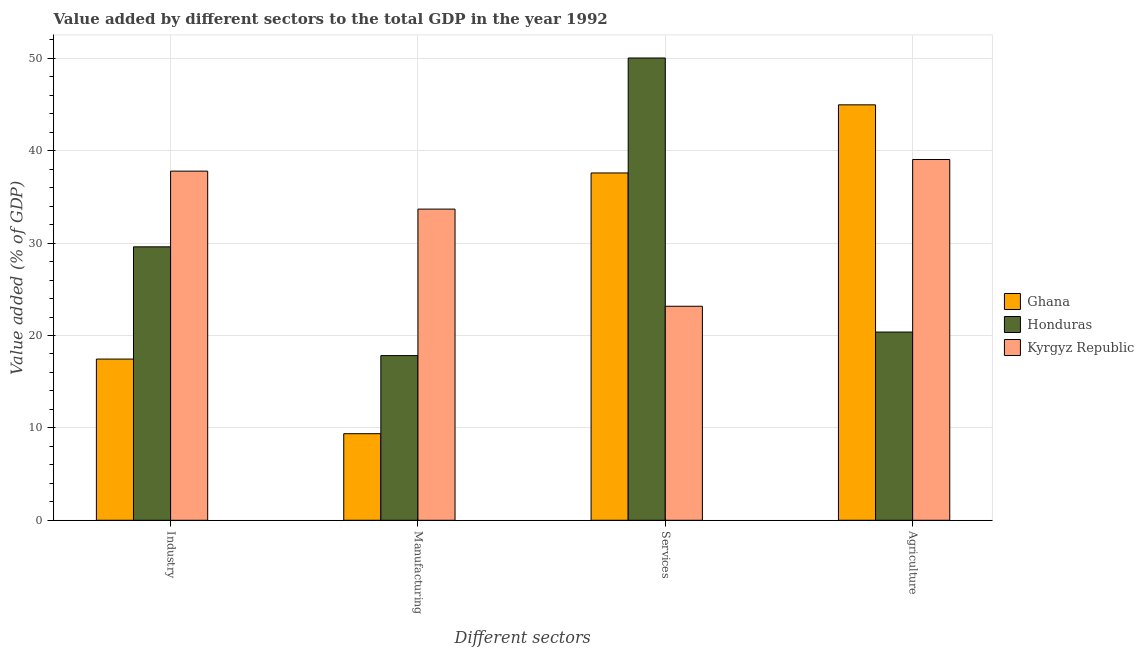Are the number of bars per tick equal to the number of legend labels?
Provide a short and direct response. Yes. Are the number of bars on each tick of the X-axis equal?
Provide a succinct answer. Yes. What is the label of the 1st group of bars from the left?
Make the answer very short. Industry. What is the value added by services sector in Kyrgyz Republic?
Ensure brevity in your answer.  23.16. Across all countries, what is the maximum value added by services sector?
Your response must be concise. 50.03. Across all countries, what is the minimum value added by agricultural sector?
Your answer should be compact. 20.37. In which country was the value added by industrial sector maximum?
Provide a short and direct response. Kyrgyz Republic. In which country was the value added by services sector minimum?
Provide a short and direct response. Kyrgyz Republic. What is the total value added by agricultural sector in the graph?
Provide a short and direct response. 104.38. What is the difference between the value added by agricultural sector in Kyrgyz Republic and that in Honduras?
Offer a very short reply. 18.68. What is the difference between the value added by agricultural sector in Honduras and the value added by industrial sector in Ghana?
Give a very brief answer. 2.92. What is the average value added by manufacturing sector per country?
Your answer should be very brief. 20.29. What is the difference between the value added by agricultural sector and value added by manufacturing sector in Kyrgyz Republic?
Provide a succinct answer. 5.37. What is the ratio of the value added by services sector in Ghana to that in Kyrgyz Republic?
Offer a terse response. 1.62. Is the value added by industrial sector in Kyrgyz Republic less than that in Honduras?
Keep it short and to the point. No. Is the difference between the value added by services sector in Ghana and Kyrgyz Republic greater than the difference between the value added by agricultural sector in Ghana and Kyrgyz Republic?
Make the answer very short. Yes. What is the difference between the highest and the second highest value added by agricultural sector?
Your answer should be compact. 5.92. What is the difference between the highest and the lowest value added by industrial sector?
Offer a very short reply. 20.34. Is the sum of the value added by manufacturing sector in Honduras and Kyrgyz Republic greater than the maximum value added by agricultural sector across all countries?
Give a very brief answer. Yes. What does the 3rd bar from the left in Services represents?
Provide a short and direct response. Kyrgyz Republic. What does the 1st bar from the right in Industry represents?
Provide a succinct answer. Kyrgyz Republic. How many countries are there in the graph?
Make the answer very short. 3. Does the graph contain grids?
Your response must be concise. Yes. Where does the legend appear in the graph?
Your answer should be compact. Center right. How many legend labels are there?
Your answer should be very brief. 3. What is the title of the graph?
Give a very brief answer. Value added by different sectors to the total GDP in the year 1992. Does "Slovak Republic" appear as one of the legend labels in the graph?
Your answer should be compact. No. What is the label or title of the X-axis?
Keep it short and to the point. Different sectors. What is the label or title of the Y-axis?
Your answer should be compact. Value added (% of GDP). What is the Value added (% of GDP) in Ghana in Industry?
Provide a short and direct response. 17.45. What is the Value added (% of GDP) in Honduras in Industry?
Provide a short and direct response. 29.6. What is the Value added (% of GDP) of Kyrgyz Republic in Industry?
Offer a very short reply. 37.79. What is the Value added (% of GDP) in Ghana in Manufacturing?
Your response must be concise. 9.37. What is the Value added (% of GDP) of Honduras in Manufacturing?
Give a very brief answer. 17.82. What is the Value added (% of GDP) in Kyrgyz Republic in Manufacturing?
Make the answer very short. 33.68. What is the Value added (% of GDP) of Ghana in Services?
Provide a short and direct response. 37.59. What is the Value added (% of GDP) in Honduras in Services?
Your response must be concise. 50.03. What is the Value added (% of GDP) in Kyrgyz Republic in Services?
Your response must be concise. 23.16. What is the Value added (% of GDP) of Ghana in Agriculture?
Your answer should be very brief. 44.96. What is the Value added (% of GDP) of Honduras in Agriculture?
Keep it short and to the point. 20.37. What is the Value added (% of GDP) in Kyrgyz Republic in Agriculture?
Give a very brief answer. 39.05. Across all Different sectors, what is the maximum Value added (% of GDP) in Ghana?
Give a very brief answer. 44.96. Across all Different sectors, what is the maximum Value added (% of GDP) in Honduras?
Offer a terse response. 50.03. Across all Different sectors, what is the maximum Value added (% of GDP) of Kyrgyz Republic?
Ensure brevity in your answer.  39.05. Across all Different sectors, what is the minimum Value added (% of GDP) of Ghana?
Offer a very short reply. 9.37. Across all Different sectors, what is the minimum Value added (% of GDP) of Honduras?
Your response must be concise. 17.82. Across all Different sectors, what is the minimum Value added (% of GDP) of Kyrgyz Republic?
Provide a short and direct response. 23.16. What is the total Value added (% of GDP) of Ghana in the graph?
Your answer should be compact. 109.37. What is the total Value added (% of GDP) of Honduras in the graph?
Provide a short and direct response. 117.82. What is the total Value added (% of GDP) in Kyrgyz Republic in the graph?
Keep it short and to the point. 133.68. What is the difference between the Value added (% of GDP) of Ghana in Industry and that in Manufacturing?
Make the answer very short. 8.08. What is the difference between the Value added (% of GDP) of Honduras in Industry and that in Manufacturing?
Your answer should be compact. 11.77. What is the difference between the Value added (% of GDP) in Kyrgyz Republic in Industry and that in Manufacturing?
Provide a short and direct response. 4.11. What is the difference between the Value added (% of GDP) in Ghana in Industry and that in Services?
Provide a succinct answer. -20.14. What is the difference between the Value added (% of GDP) of Honduras in Industry and that in Services?
Provide a succinct answer. -20.44. What is the difference between the Value added (% of GDP) of Kyrgyz Republic in Industry and that in Services?
Provide a succinct answer. 14.62. What is the difference between the Value added (% of GDP) of Ghana in Industry and that in Agriculture?
Offer a terse response. -27.52. What is the difference between the Value added (% of GDP) in Honduras in Industry and that in Agriculture?
Provide a succinct answer. 9.22. What is the difference between the Value added (% of GDP) in Kyrgyz Republic in Industry and that in Agriculture?
Keep it short and to the point. -1.26. What is the difference between the Value added (% of GDP) in Ghana in Manufacturing and that in Services?
Ensure brevity in your answer.  -28.22. What is the difference between the Value added (% of GDP) of Honduras in Manufacturing and that in Services?
Your answer should be very brief. -32.21. What is the difference between the Value added (% of GDP) of Kyrgyz Republic in Manufacturing and that in Services?
Your answer should be compact. 10.51. What is the difference between the Value added (% of GDP) of Ghana in Manufacturing and that in Agriculture?
Your response must be concise. -35.59. What is the difference between the Value added (% of GDP) in Honduras in Manufacturing and that in Agriculture?
Provide a short and direct response. -2.55. What is the difference between the Value added (% of GDP) in Kyrgyz Republic in Manufacturing and that in Agriculture?
Ensure brevity in your answer.  -5.37. What is the difference between the Value added (% of GDP) in Ghana in Services and that in Agriculture?
Your response must be concise. -7.37. What is the difference between the Value added (% of GDP) of Honduras in Services and that in Agriculture?
Your answer should be very brief. 29.66. What is the difference between the Value added (% of GDP) of Kyrgyz Republic in Services and that in Agriculture?
Offer a terse response. -15.88. What is the difference between the Value added (% of GDP) in Ghana in Industry and the Value added (% of GDP) in Honduras in Manufacturing?
Your answer should be very brief. -0.38. What is the difference between the Value added (% of GDP) in Ghana in Industry and the Value added (% of GDP) in Kyrgyz Republic in Manufacturing?
Keep it short and to the point. -16.23. What is the difference between the Value added (% of GDP) of Honduras in Industry and the Value added (% of GDP) of Kyrgyz Republic in Manufacturing?
Your answer should be very brief. -4.08. What is the difference between the Value added (% of GDP) of Ghana in Industry and the Value added (% of GDP) of Honduras in Services?
Provide a short and direct response. -32.59. What is the difference between the Value added (% of GDP) of Ghana in Industry and the Value added (% of GDP) of Kyrgyz Republic in Services?
Your answer should be very brief. -5.72. What is the difference between the Value added (% of GDP) in Honduras in Industry and the Value added (% of GDP) in Kyrgyz Republic in Services?
Your answer should be very brief. 6.43. What is the difference between the Value added (% of GDP) in Ghana in Industry and the Value added (% of GDP) in Honduras in Agriculture?
Your response must be concise. -2.92. What is the difference between the Value added (% of GDP) in Ghana in Industry and the Value added (% of GDP) in Kyrgyz Republic in Agriculture?
Your answer should be compact. -21.6. What is the difference between the Value added (% of GDP) of Honduras in Industry and the Value added (% of GDP) of Kyrgyz Republic in Agriculture?
Provide a short and direct response. -9.45. What is the difference between the Value added (% of GDP) in Ghana in Manufacturing and the Value added (% of GDP) in Honduras in Services?
Your answer should be compact. -40.66. What is the difference between the Value added (% of GDP) of Ghana in Manufacturing and the Value added (% of GDP) of Kyrgyz Republic in Services?
Give a very brief answer. -13.79. What is the difference between the Value added (% of GDP) in Honduras in Manufacturing and the Value added (% of GDP) in Kyrgyz Republic in Services?
Provide a succinct answer. -5.34. What is the difference between the Value added (% of GDP) in Ghana in Manufacturing and the Value added (% of GDP) in Honduras in Agriculture?
Ensure brevity in your answer.  -11. What is the difference between the Value added (% of GDP) of Ghana in Manufacturing and the Value added (% of GDP) of Kyrgyz Republic in Agriculture?
Provide a succinct answer. -29.68. What is the difference between the Value added (% of GDP) in Honduras in Manufacturing and the Value added (% of GDP) in Kyrgyz Republic in Agriculture?
Your answer should be compact. -21.23. What is the difference between the Value added (% of GDP) in Ghana in Services and the Value added (% of GDP) in Honduras in Agriculture?
Provide a succinct answer. 17.22. What is the difference between the Value added (% of GDP) in Ghana in Services and the Value added (% of GDP) in Kyrgyz Republic in Agriculture?
Provide a succinct answer. -1.46. What is the difference between the Value added (% of GDP) in Honduras in Services and the Value added (% of GDP) in Kyrgyz Republic in Agriculture?
Your answer should be compact. 10.99. What is the average Value added (% of GDP) in Ghana per Different sectors?
Provide a short and direct response. 27.34. What is the average Value added (% of GDP) in Honduras per Different sectors?
Your answer should be compact. 29.46. What is the average Value added (% of GDP) in Kyrgyz Republic per Different sectors?
Your response must be concise. 33.42. What is the difference between the Value added (% of GDP) of Ghana and Value added (% of GDP) of Honduras in Industry?
Your answer should be compact. -12.15. What is the difference between the Value added (% of GDP) in Ghana and Value added (% of GDP) in Kyrgyz Republic in Industry?
Provide a short and direct response. -20.34. What is the difference between the Value added (% of GDP) in Honduras and Value added (% of GDP) in Kyrgyz Republic in Industry?
Provide a short and direct response. -8.19. What is the difference between the Value added (% of GDP) of Ghana and Value added (% of GDP) of Honduras in Manufacturing?
Offer a very short reply. -8.45. What is the difference between the Value added (% of GDP) of Ghana and Value added (% of GDP) of Kyrgyz Republic in Manufacturing?
Give a very brief answer. -24.31. What is the difference between the Value added (% of GDP) of Honduras and Value added (% of GDP) of Kyrgyz Republic in Manufacturing?
Ensure brevity in your answer.  -15.86. What is the difference between the Value added (% of GDP) of Ghana and Value added (% of GDP) of Honduras in Services?
Give a very brief answer. -12.44. What is the difference between the Value added (% of GDP) in Ghana and Value added (% of GDP) in Kyrgyz Republic in Services?
Provide a short and direct response. 14.43. What is the difference between the Value added (% of GDP) in Honduras and Value added (% of GDP) in Kyrgyz Republic in Services?
Offer a terse response. 26.87. What is the difference between the Value added (% of GDP) of Ghana and Value added (% of GDP) of Honduras in Agriculture?
Make the answer very short. 24.59. What is the difference between the Value added (% of GDP) of Ghana and Value added (% of GDP) of Kyrgyz Republic in Agriculture?
Your response must be concise. 5.92. What is the difference between the Value added (% of GDP) in Honduras and Value added (% of GDP) in Kyrgyz Republic in Agriculture?
Make the answer very short. -18.68. What is the ratio of the Value added (% of GDP) in Ghana in Industry to that in Manufacturing?
Make the answer very short. 1.86. What is the ratio of the Value added (% of GDP) in Honduras in Industry to that in Manufacturing?
Provide a succinct answer. 1.66. What is the ratio of the Value added (% of GDP) in Kyrgyz Republic in Industry to that in Manufacturing?
Offer a very short reply. 1.12. What is the ratio of the Value added (% of GDP) of Ghana in Industry to that in Services?
Make the answer very short. 0.46. What is the ratio of the Value added (% of GDP) in Honduras in Industry to that in Services?
Provide a short and direct response. 0.59. What is the ratio of the Value added (% of GDP) of Kyrgyz Republic in Industry to that in Services?
Your response must be concise. 1.63. What is the ratio of the Value added (% of GDP) of Ghana in Industry to that in Agriculture?
Offer a terse response. 0.39. What is the ratio of the Value added (% of GDP) of Honduras in Industry to that in Agriculture?
Provide a short and direct response. 1.45. What is the ratio of the Value added (% of GDP) in Ghana in Manufacturing to that in Services?
Your answer should be very brief. 0.25. What is the ratio of the Value added (% of GDP) of Honduras in Manufacturing to that in Services?
Offer a very short reply. 0.36. What is the ratio of the Value added (% of GDP) of Kyrgyz Republic in Manufacturing to that in Services?
Your answer should be very brief. 1.45. What is the ratio of the Value added (% of GDP) in Ghana in Manufacturing to that in Agriculture?
Provide a short and direct response. 0.21. What is the ratio of the Value added (% of GDP) of Honduras in Manufacturing to that in Agriculture?
Make the answer very short. 0.87. What is the ratio of the Value added (% of GDP) of Kyrgyz Republic in Manufacturing to that in Agriculture?
Ensure brevity in your answer.  0.86. What is the ratio of the Value added (% of GDP) in Ghana in Services to that in Agriculture?
Provide a short and direct response. 0.84. What is the ratio of the Value added (% of GDP) of Honduras in Services to that in Agriculture?
Your answer should be compact. 2.46. What is the ratio of the Value added (% of GDP) of Kyrgyz Republic in Services to that in Agriculture?
Make the answer very short. 0.59. What is the difference between the highest and the second highest Value added (% of GDP) in Ghana?
Offer a terse response. 7.37. What is the difference between the highest and the second highest Value added (% of GDP) of Honduras?
Give a very brief answer. 20.44. What is the difference between the highest and the second highest Value added (% of GDP) in Kyrgyz Republic?
Give a very brief answer. 1.26. What is the difference between the highest and the lowest Value added (% of GDP) of Ghana?
Provide a succinct answer. 35.59. What is the difference between the highest and the lowest Value added (% of GDP) of Honduras?
Keep it short and to the point. 32.21. What is the difference between the highest and the lowest Value added (% of GDP) of Kyrgyz Republic?
Offer a very short reply. 15.88. 